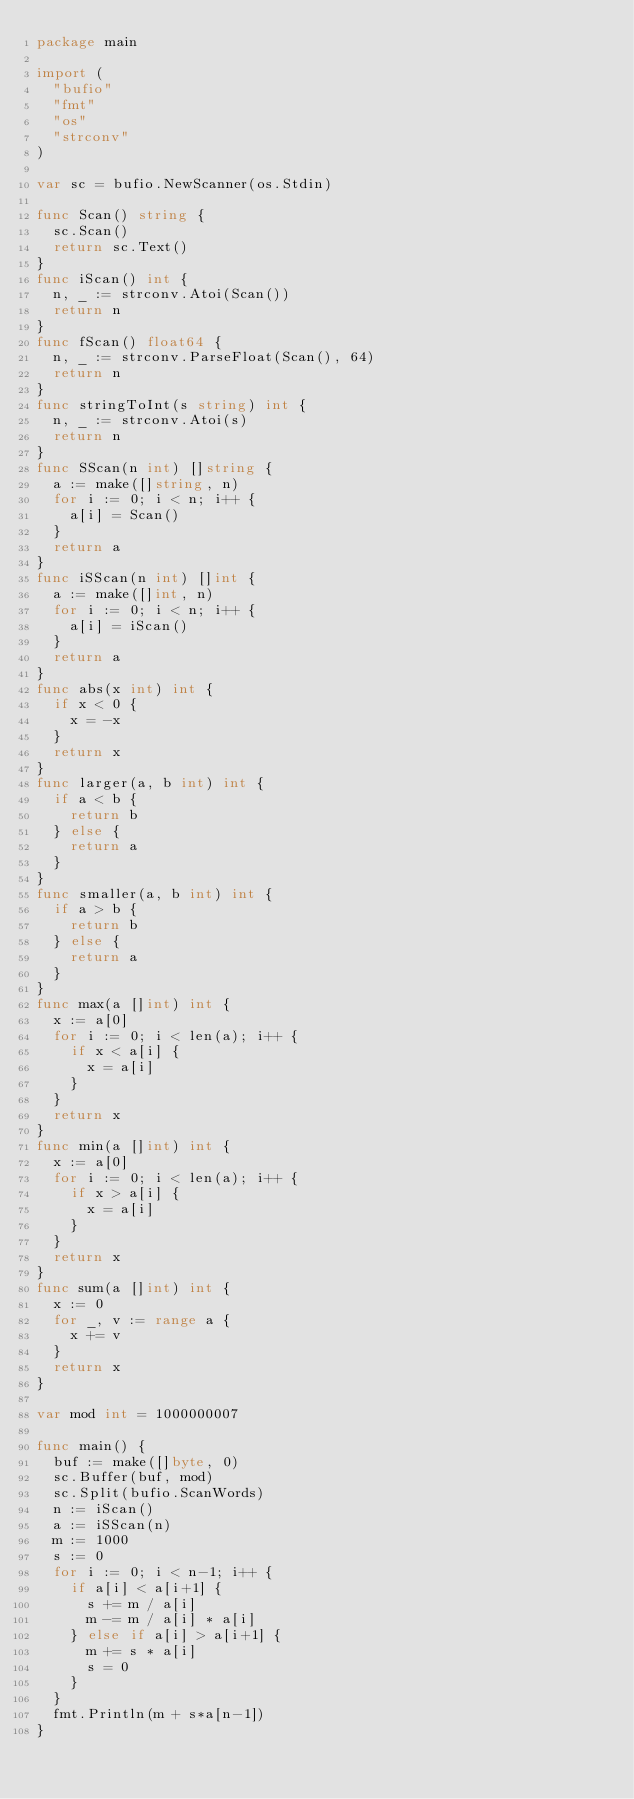<code> <loc_0><loc_0><loc_500><loc_500><_Go_>package main

import (
	"bufio"
	"fmt"
	"os"
	"strconv"
)

var sc = bufio.NewScanner(os.Stdin)

func Scan() string {
	sc.Scan()
	return sc.Text()
}
func iScan() int {
	n, _ := strconv.Atoi(Scan())
	return n
}
func fScan() float64 {
	n, _ := strconv.ParseFloat(Scan(), 64)
	return n
}
func stringToInt(s string) int {
	n, _ := strconv.Atoi(s)
	return n
}
func SScan(n int) []string {
	a := make([]string, n)
	for i := 0; i < n; i++ {
		a[i] = Scan()
	}
	return a
}
func iSScan(n int) []int {
	a := make([]int, n)
	for i := 0; i < n; i++ {
		a[i] = iScan()
	}
	return a
}
func abs(x int) int {
	if x < 0 {
		x = -x
	}
	return x
}
func larger(a, b int) int {
	if a < b {
		return b
	} else {
		return a
	}
}
func smaller(a, b int) int {
	if a > b {
		return b
	} else {
		return a
	}
}
func max(a []int) int {
	x := a[0]
	for i := 0; i < len(a); i++ {
		if x < a[i] {
			x = a[i]
		}
	}
	return x
}
func min(a []int) int {
	x := a[0]
	for i := 0; i < len(a); i++ {
		if x > a[i] {
			x = a[i]
		}
	}
	return x
}
func sum(a []int) int {
	x := 0
	for _, v := range a {
		x += v
	}
	return x
}

var mod int = 1000000007

func main() {
	buf := make([]byte, 0)
	sc.Buffer(buf, mod)
	sc.Split(bufio.ScanWords)
	n := iScan()
	a := iSScan(n)
	m := 1000
	s := 0
	for i := 0; i < n-1; i++ {
		if a[i] < a[i+1] {
			s += m / a[i]
			m -= m / a[i] * a[i]
		} else if a[i] > a[i+1] {
			m += s * a[i]
			s = 0
		}
	}
	fmt.Println(m + s*a[n-1])
}
</code> 